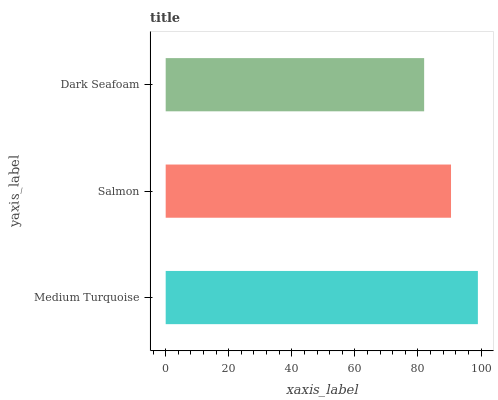Is Dark Seafoam the minimum?
Answer yes or no. Yes. Is Medium Turquoise the maximum?
Answer yes or no. Yes. Is Salmon the minimum?
Answer yes or no. No. Is Salmon the maximum?
Answer yes or no. No. Is Medium Turquoise greater than Salmon?
Answer yes or no. Yes. Is Salmon less than Medium Turquoise?
Answer yes or no. Yes. Is Salmon greater than Medium Turquoise?
Answer yes or no. No. Is Medium Turquoise less than Salmon?
Answer yes or no. No. Is Salmon the high median?
Answer yes or no. Yes. Is Salmon the low median?
Answer yes or no. Yes. Is Dark Seafoam the high median?
Answer yes or no. No. Is Medium Turquoise the low median?
Answer yes or no. No. 